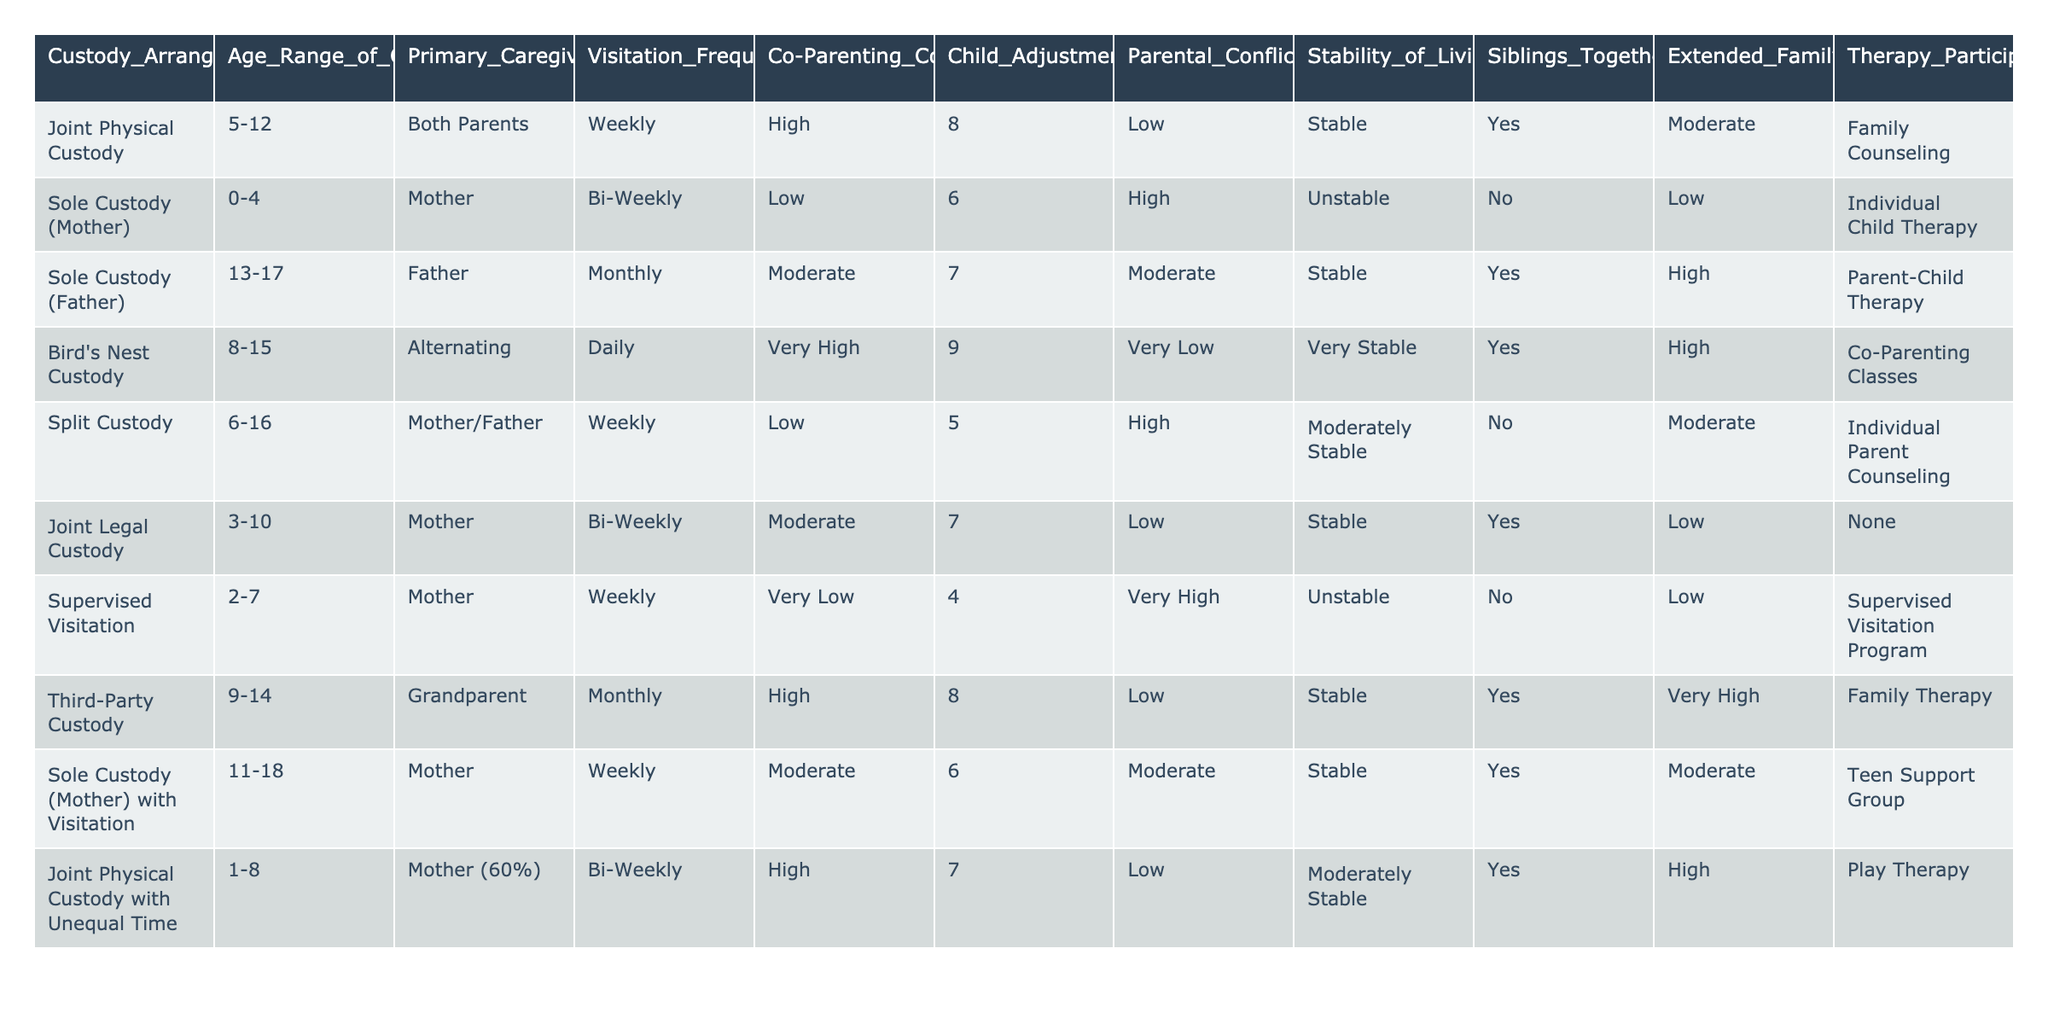What is the primary caregiver in the Sole Custody (Mother) arrangement? The table shows that the primary caregiver in the Sole Custody (Mother) arrangement is the Mother.
Answer: Mother How often do children have visitation in the Bird's Nest Custody arrangement? According to the table, children in the Bird's Nest Custody arrangement have daily visitation.
Answer: Daily Which custody arrangement has the highest Child Adjustment Score? In the table, Bird's Nest Custody has the highest Child Adjustment Score of 9.
Answer: 9 In which custody type do siblings stay together? The table indicates that siblings stay together in Joint Physical Custody, Bird's Nest Custody, Third-Party Custody, and Sole Custody (Mother) with Visitation.
Answer: Joint Physical Custody, Bird's Nest Custody, Third-Party Custody, Sole Custody (Mother) with Visitation What is the average Child Adjustment Score for Sole Custody arrangements? Sole Custody arrangements in the table are Sole Custody (Mother) and Sole Custody (Father), with scores of 6 and 7 respectively. The average is (6 + 7) / 2 = 6.5.
Answer: 6.5 Is there any therapy participation reported for the Split Custody arrangement? The table shows that there is no therapy participation reported for the Split Custody arrangement.
Answer: No What is the relationship between visitation frequency and parental conflict levels for Joint Physical Custody? In Joint Physical Custody, visitation is weekly, and parental conflict is low. This suggests that higher visitation frequency correlates with lower parental conflict.
Answer: Observed relationship is low conflict with weekly visitation What type of custody arrangement includes both parents as primary caregivers? The table indicates that Joint Physical Custody includes both parents as primary caregivers.
Answer: Joint Physical Custody Which custody arrangement has the highest level of co-parenting communication? The table shows that Bird's Nest Custody has a very high level of co-parenting communication.
Answer: Very High Do children in Supervised Visitation experience high parental conflict? The table indicates that Supervised Visitation has a very high level of parental conflict.
Answer: Yes, very high What is the combined stability of living situations for custody arrangements where children have therapy participation? The table lists Bird's Nest Custody, Third-Party Custody, Sole Custody (Mother) with Visitation, and Joint Physical Custody with Unequal Time with stable living situations. Combined stability results in 3 stable arrangements.
Answer: 3 stable arrangements 